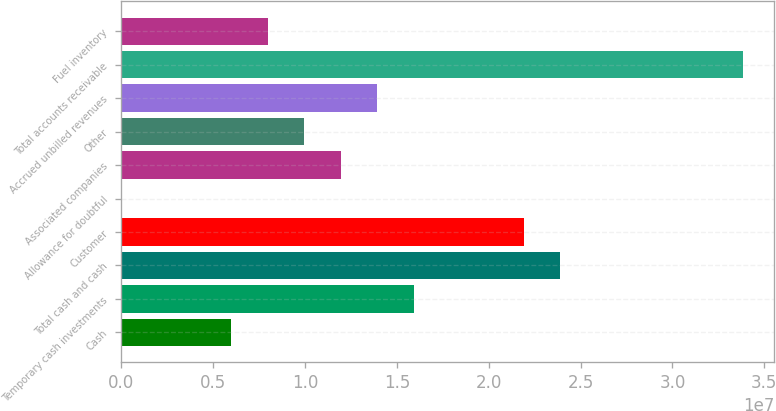Convert chart to OTSL. <chart><loc_0><loc_0><loc_500><loc_500><bar_chart><fcel>Cash<fcel>Temporary cash investments<fcel>Total cash and cash<fcel>Customer<fcel>Allowance for doubtful<fcel>Associated companies<fcel>Other<fcel>Accrued unbilled revenues<fcel>Total accounts receivable<fcel>Fuel inventory<nl><fcel>5.9805e+06<fcel>1.59375e+07<fcel>2.39032e+07<fcel>2.19118e+07<fcel>6277<fcel>1.19547e+07<fcel>9.96332e+06<fcel>1.39461e+07<fcel>3.38602e+07<fcel>7.97191e+06<nl></chart> 